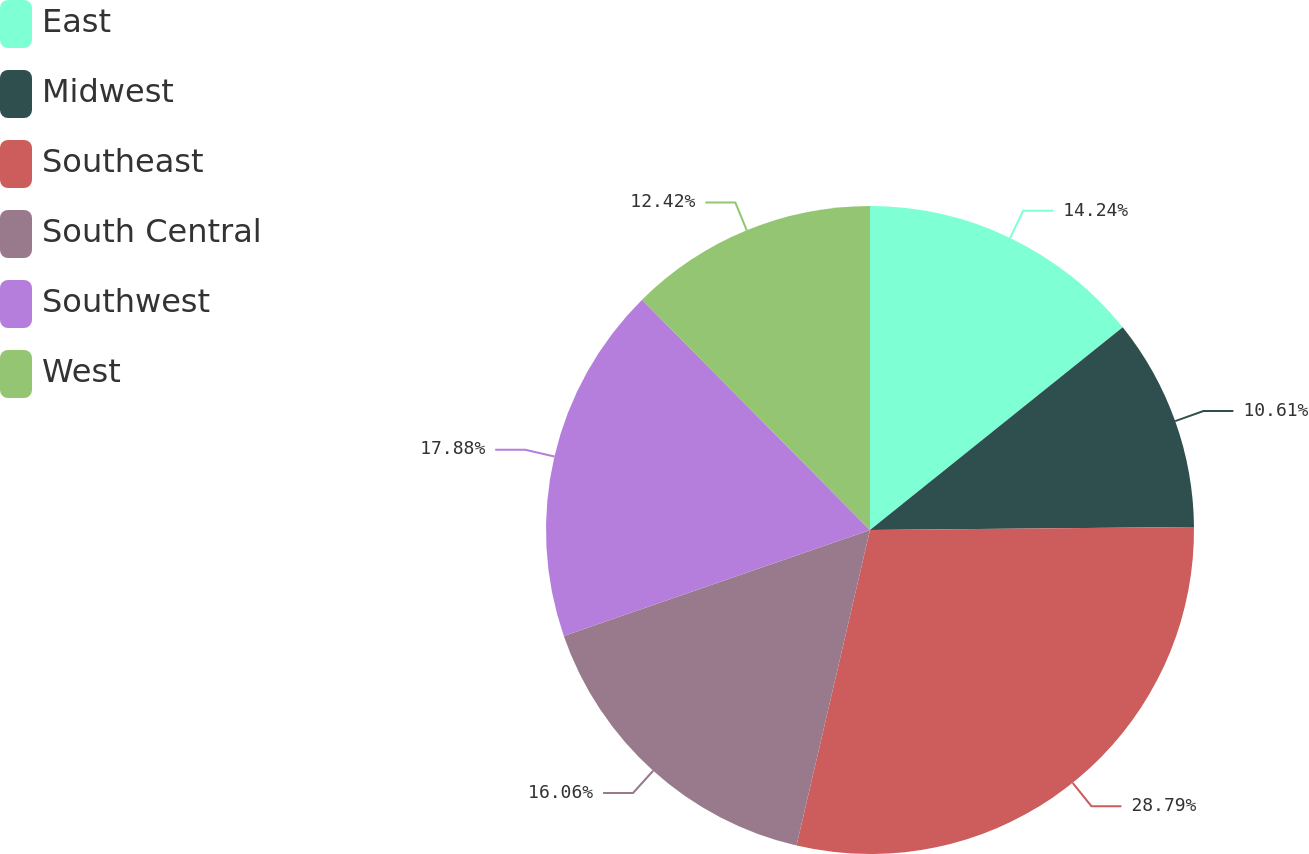Convert chart to OTSL. <chart><loc_0><loc_0><loc_500><loc_500><pie_chart><fcel>East<fcel>Midwest<fcel>Southeast<fcel>South Central<fcel>Southwest<fcel>West<nl><fcel>14.24%<fcel>10.61%<fcel>28.79%<fcel>16.06%<fcel>17.88%<fcel>12.42%<nl></chart> 